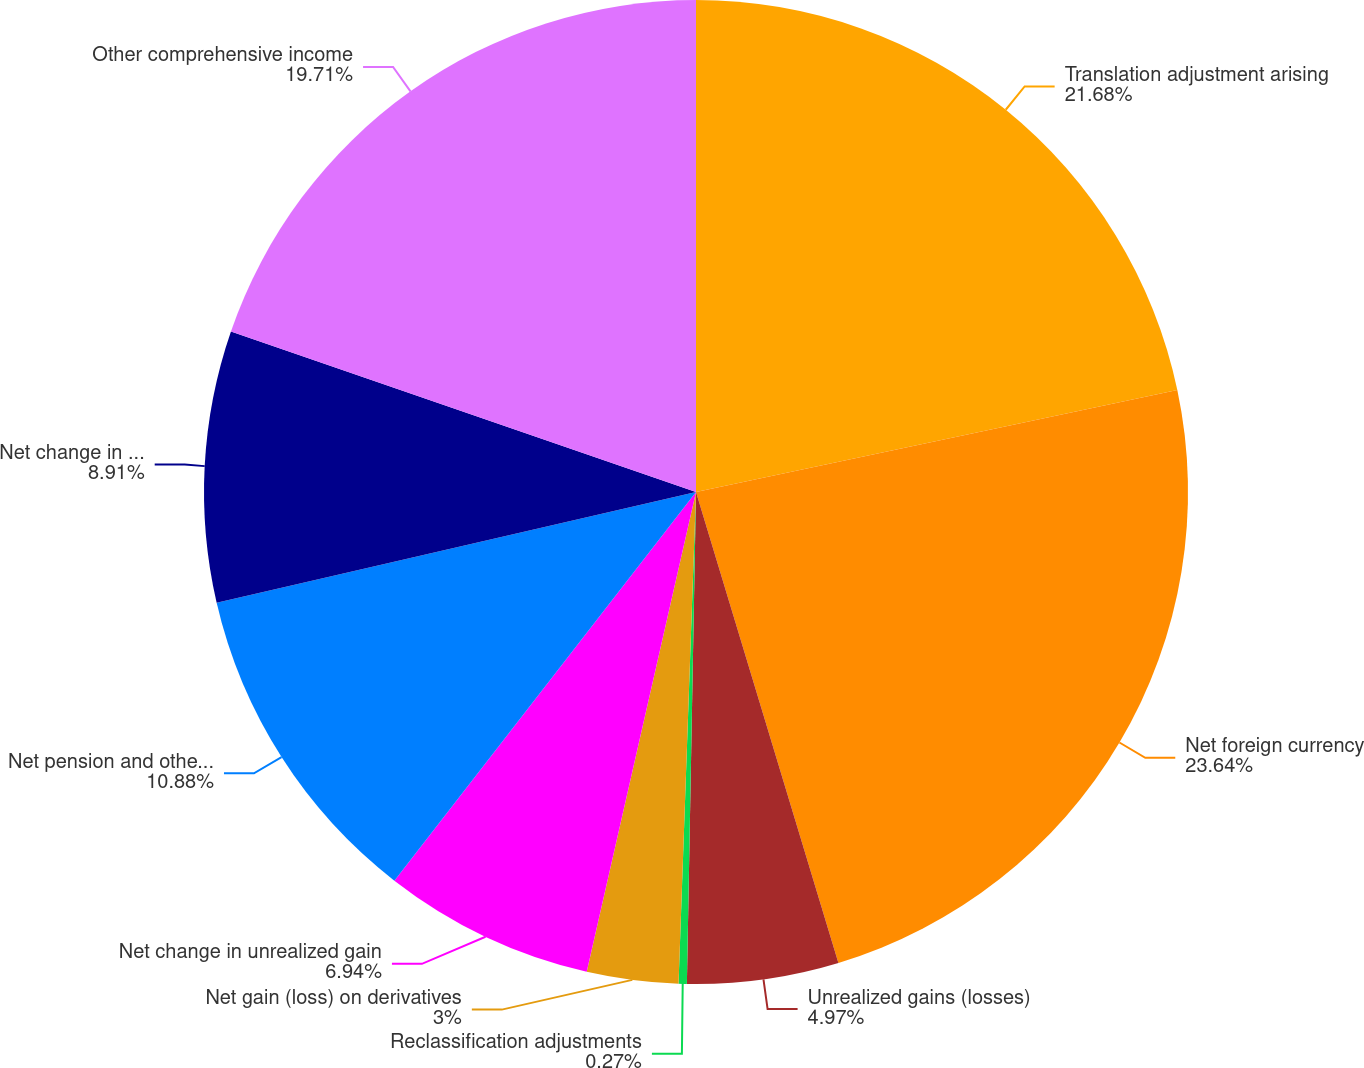Convert chart. <chart><loc_0><loc_0><loc_500><loc_500><pie_chart><fcel>Translation adjustment arising<fcel>Net foreign currency<fcel>Unrealized gains (losses)<fcel>Reclassification adjustments<fcel>Net gain (loss) on derivatives<fcel>Net change in unrealized gain<fcel>Net pension and other benefits<fcel>Net change in pension and<fcel>Other comprehensive income<nl><fcel>21.68%<fcel>23.65%<fcel>4.97%<fcel>0.27%<fcel>3.0%<fcel>6.94%<fcel>10.88%<fcel>8.91%<fcel>19.71%<nl></chart> 